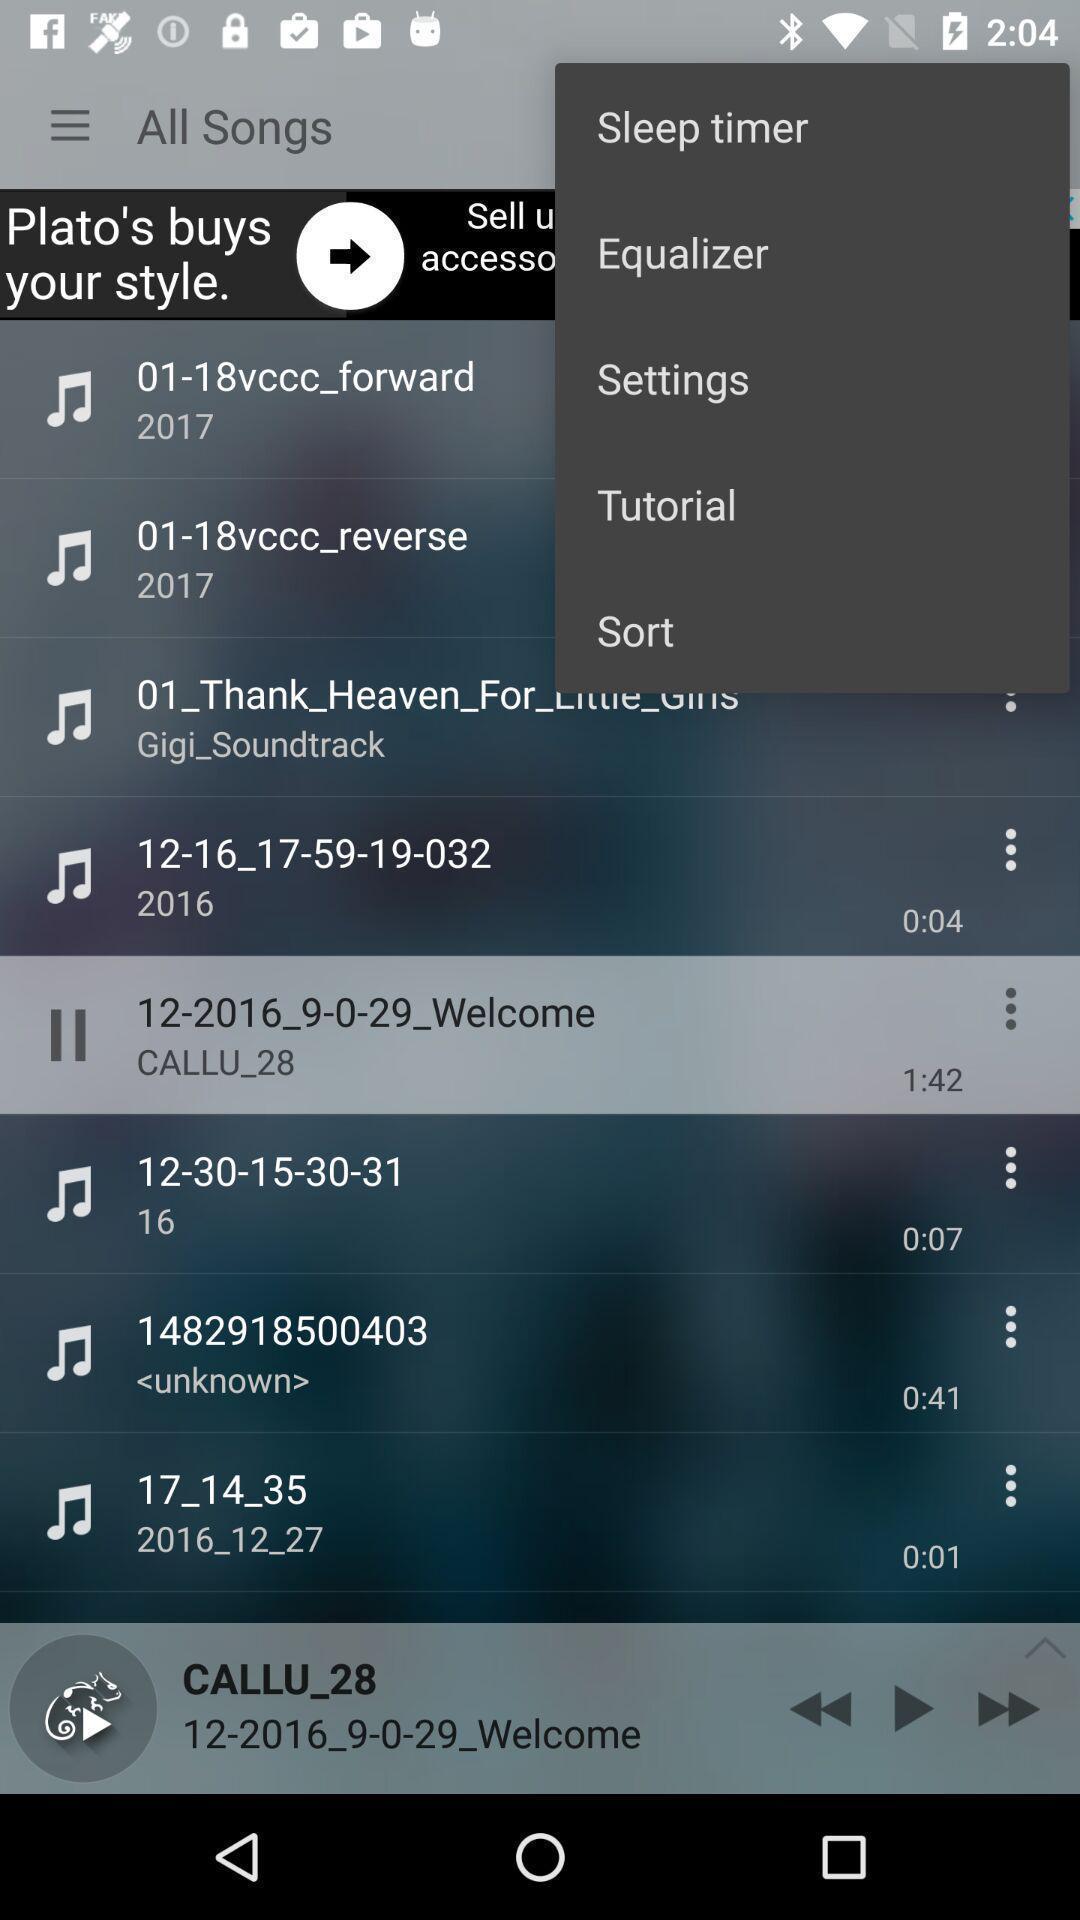Provide a detailed account of this screenshot. Screen shows options in audio player. 